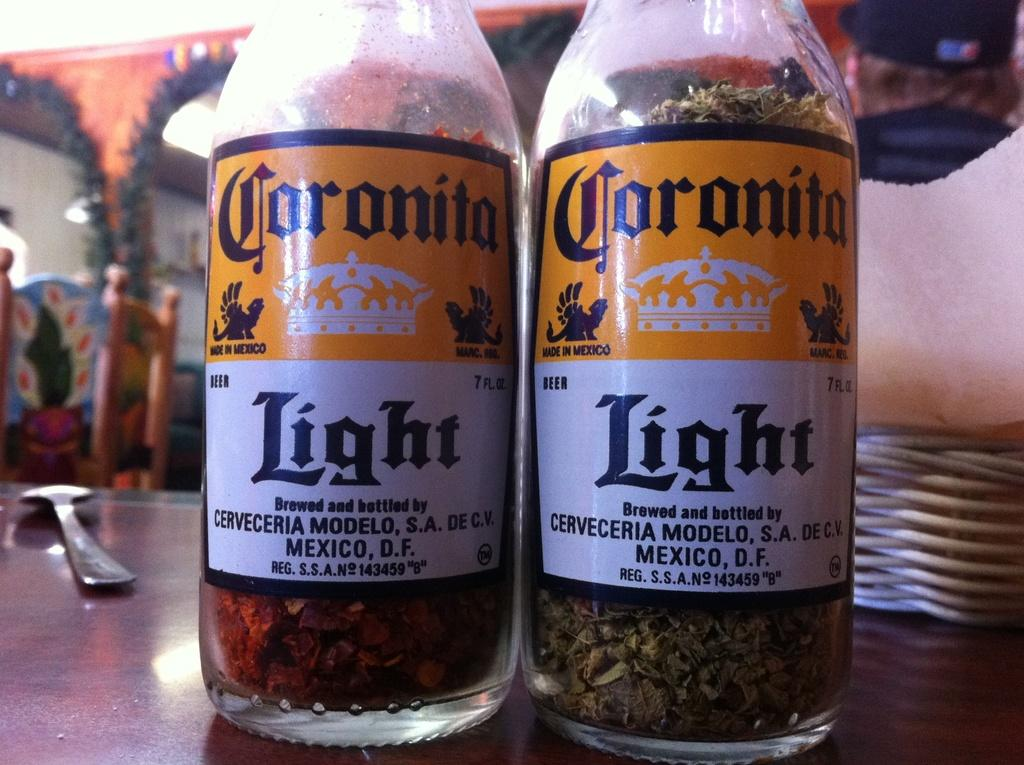How many bottles are visible in the picture? There are two bottles in the picture. What else can be seen in the right corner of the picture? There is a spoon in the right corner of the picture. Are there any seating objects in the image? Yes, there are chairs in the image. What type of linen is draped over the chairs in the image? There is no linen present in the image; only the bottles, spoon, and chairs are visible. 